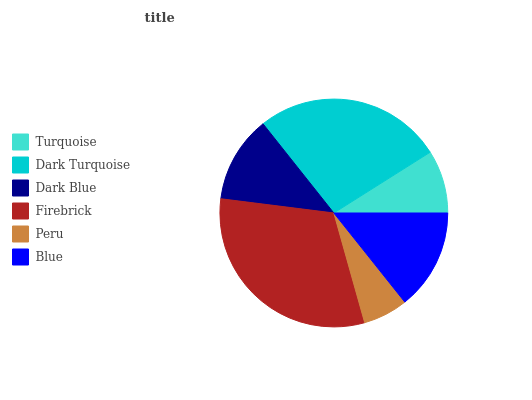Is Peru the minimum?
Answer yes or no. Yes. Is Firebrick the maximum?
Answer yes or no. Yes. Is Dark Turquoise the minimum?
Answer yes or no. No. Is Dark Turquoise the maximum?
Answer yes or no. No. Is Dark Turquoise greater than Turquoise?
Answer yes or no. Yes. Is Turquoise less than Dark Turquoise?
Answer yes or no. Yes. Is Turquoise greater than Dark Turquoise?
Answer yes or no. No. Is Dark Turquoise less than Turquoise?
Answer yes or no. No. Is Blue the high median?
Answer yes or no. Yes. Is Dark Blue the low median?
Answer yes or no. Yes. Is Dark Blue the high median?
Answer yes or no. No. Is Peru the low median?
Answer yes or no. No. 